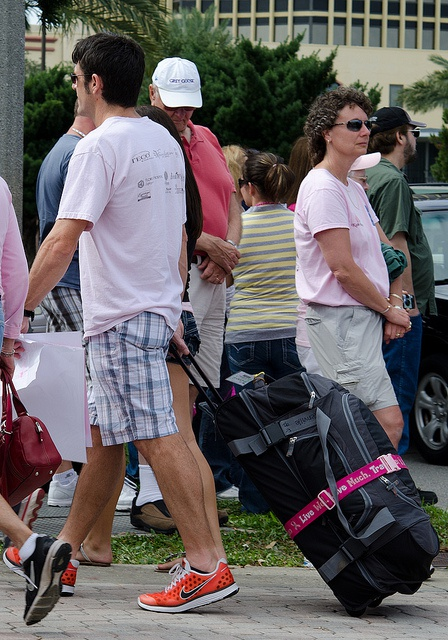Describe the objects in this image and their specific colors. I can see people in gray, darkgray, lavender, and brown tones, suitcase in gray, black, and darkblue tones, people in gray, darkgray, brown, lavender, and black tones, people in gray, brown, and black tones, and people in gray, black, darkgray, and tan tones in this image. 